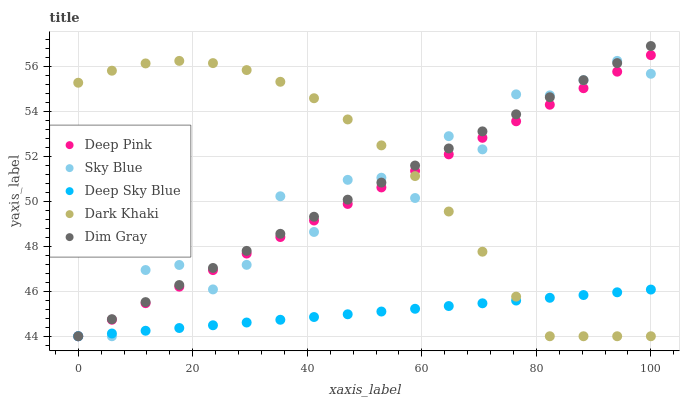Does Deep Sky Blue have the minimum area under the curve?
Answer yes or no. Yes. Does Dark Khaki have the maximum area under the curve?
Answer yes or no. Yes. Does Sky Blue have the minimum area under the curve?
Answer yes or no. No. Does Sky Blue have the maximum area under the curve?
Answer yes or no. No. Is Deep Sky Blue the smoothest?
Answer yes or no. Yes. Is Sky Blue the roughest?
Answer yes or no. Yes. Is Dim Gray the smoothest?
Answer yes or no. No. Is Dim Gray the roughest?
Answer yes or no. No. Does Dark Khaki have the lowest value?
Answer yes or no. Yes. Does Dim Gray have the highest value?
Answer yes or no. Yes. Does Sky Blue have the highest value?
Answer yes or no. No. Does Deep Pink intersect Sky Blue?
Answer yes or no. Yes. Is Deep Pink less than Sky Blue?
Answer yes or no. No. Is Deep Pink greater than Sky Blue?
Answer yes or no. No. 